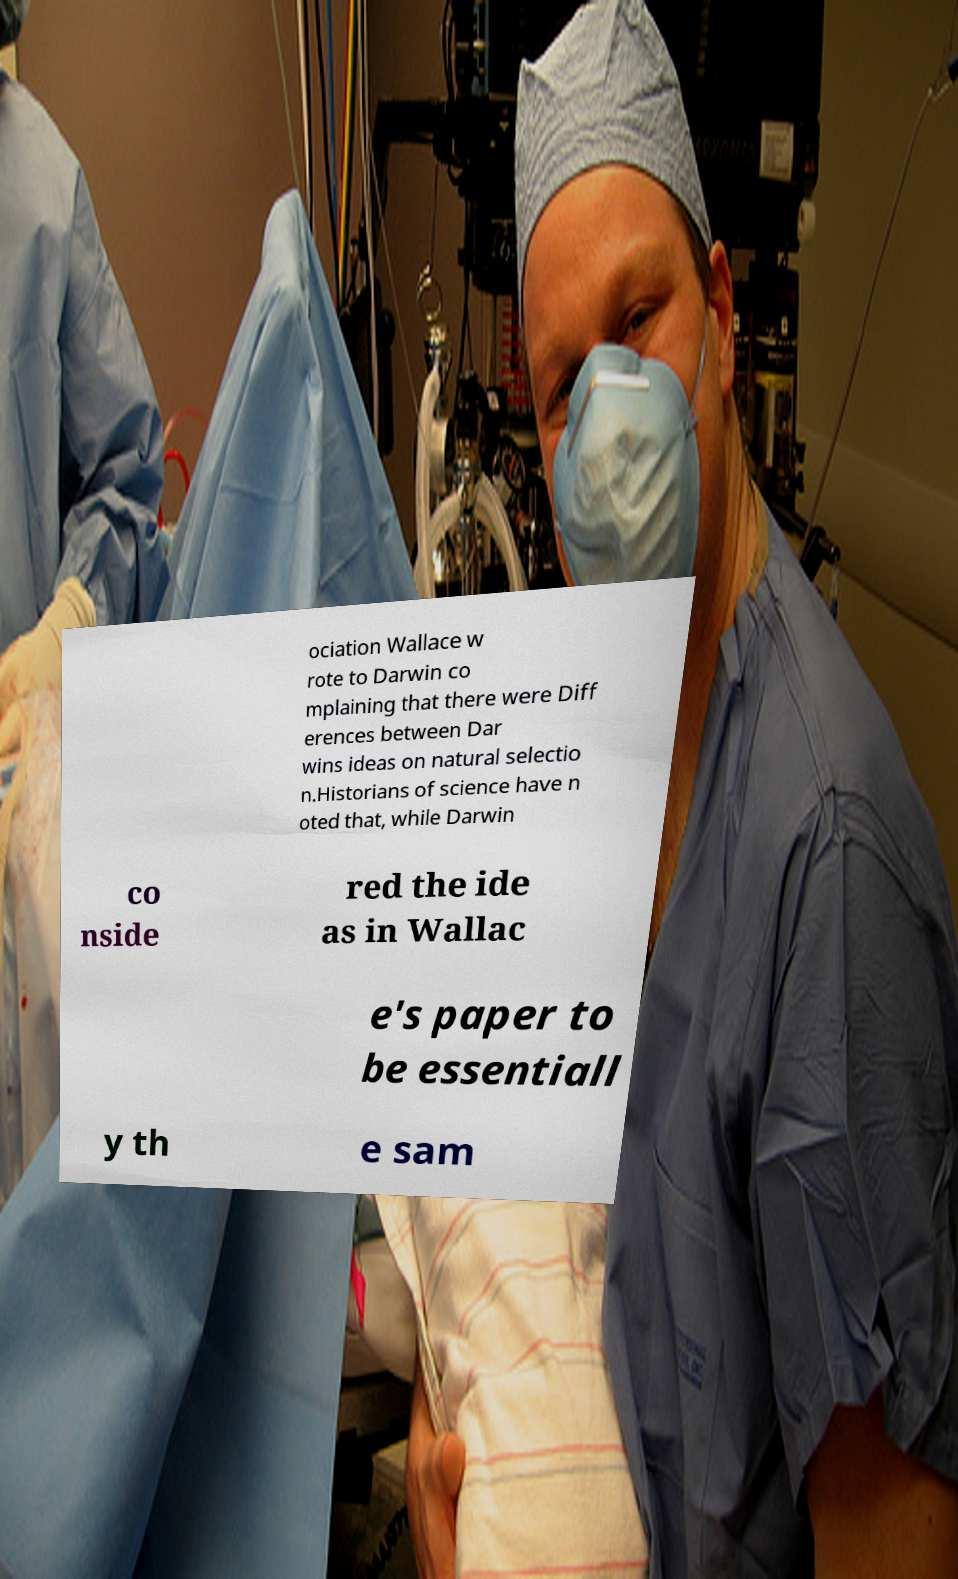For documentation purposes, I need the text within this image transcribed. Could you provide that? ociation Wallace w rote to Darwin co mplaining that there were Diff erences between Dar wins ideas on natural selectio n.Historians of science have n oted that, while Darwin co nside red the ide as in Wallac e's paper to be essentiall y th e sam 